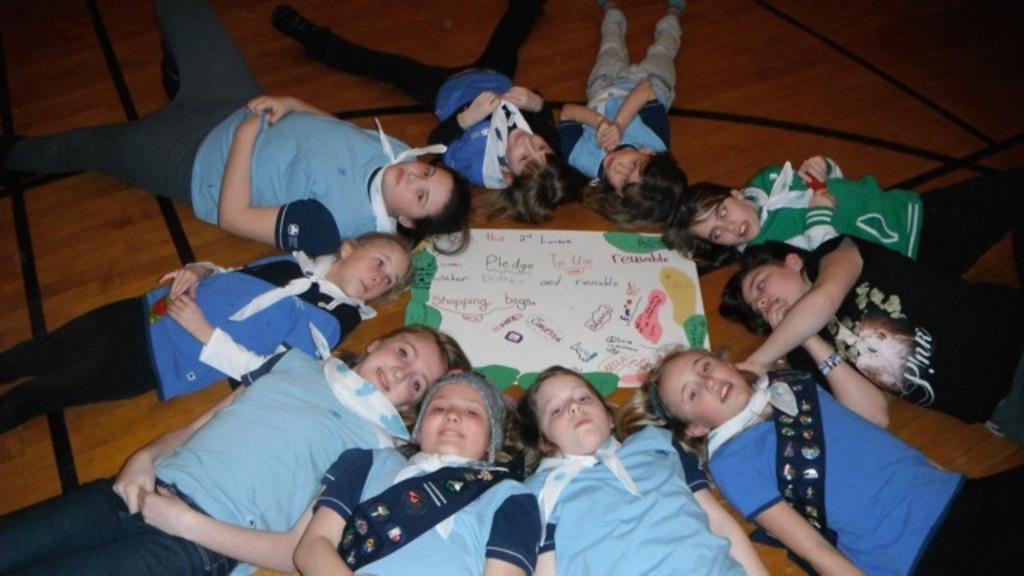Can you describe this image briefly? These people are lying on wooden surface. In-between of these people there is a poster. 